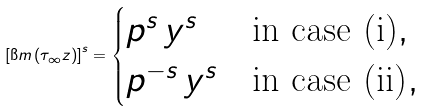Convert formula to latex. <formula><loc_0><loc_0><loc_500><loc_500>\left [ \i m \left ( \tau _ { \infty } z \right ) \right ] ^ { s } = \begin{cases} p ^ { s } \, y ^ { s } & \text {in case (i)} , \\ p ^ { - s } \, y ^ { s } & \text {in case (ii)} , \end{cases}</formula> 